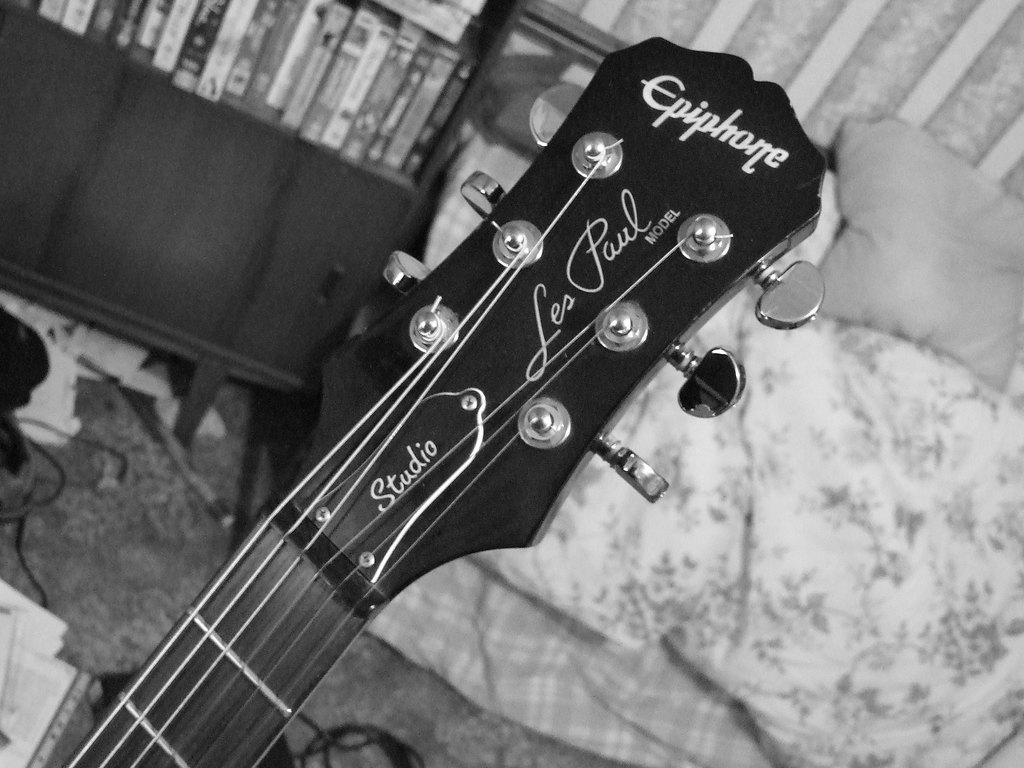What is the color scheme of the image? The image is black and white. What can be seen in the image related to a musical instrument? There is a guitar head with tuners in the image. What is the guitar rack being used for in the image? The guitar rack is filled with books in the image. What type of furniture is present in the image? There is a couch with a pillow in the image. What is on the floor in the image? There is a cable on the floor in the image. How does the turkey stretch its wings in the image? There is no turkey present in the image, so it is not possible to answer that question. 